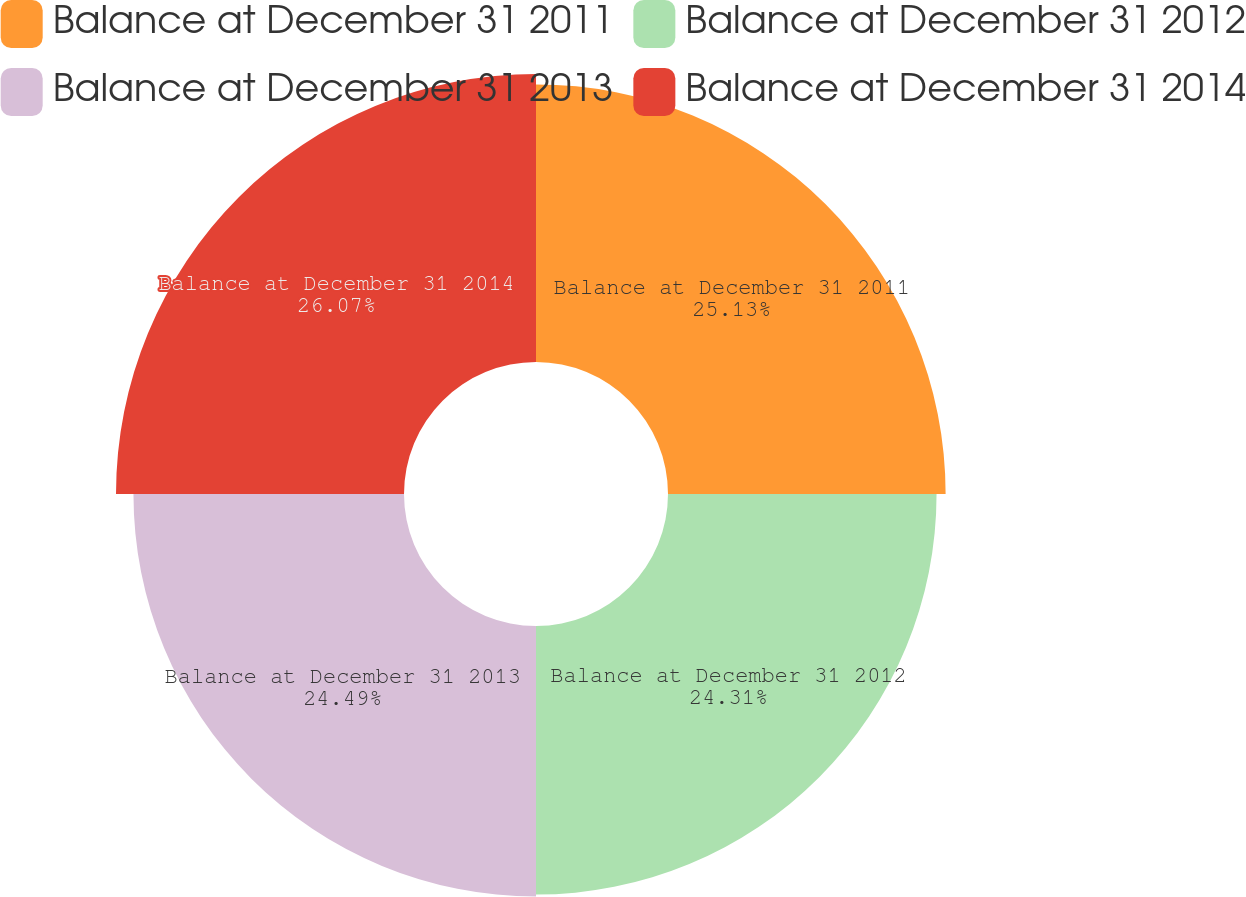Convert chart. <chart><loc_0><loc_0><loc_500><loc_500><pie_chart><fcel>Balance at December 31 2011<fcel>Balance at December 31 2012<fcel>Balance at December 31 2013<fcel>Balance at December 31 2014<nl><fcel>25.13%<fcel>24.31%<fcel>24.49%<fcel>26.07%<nl></chart> 